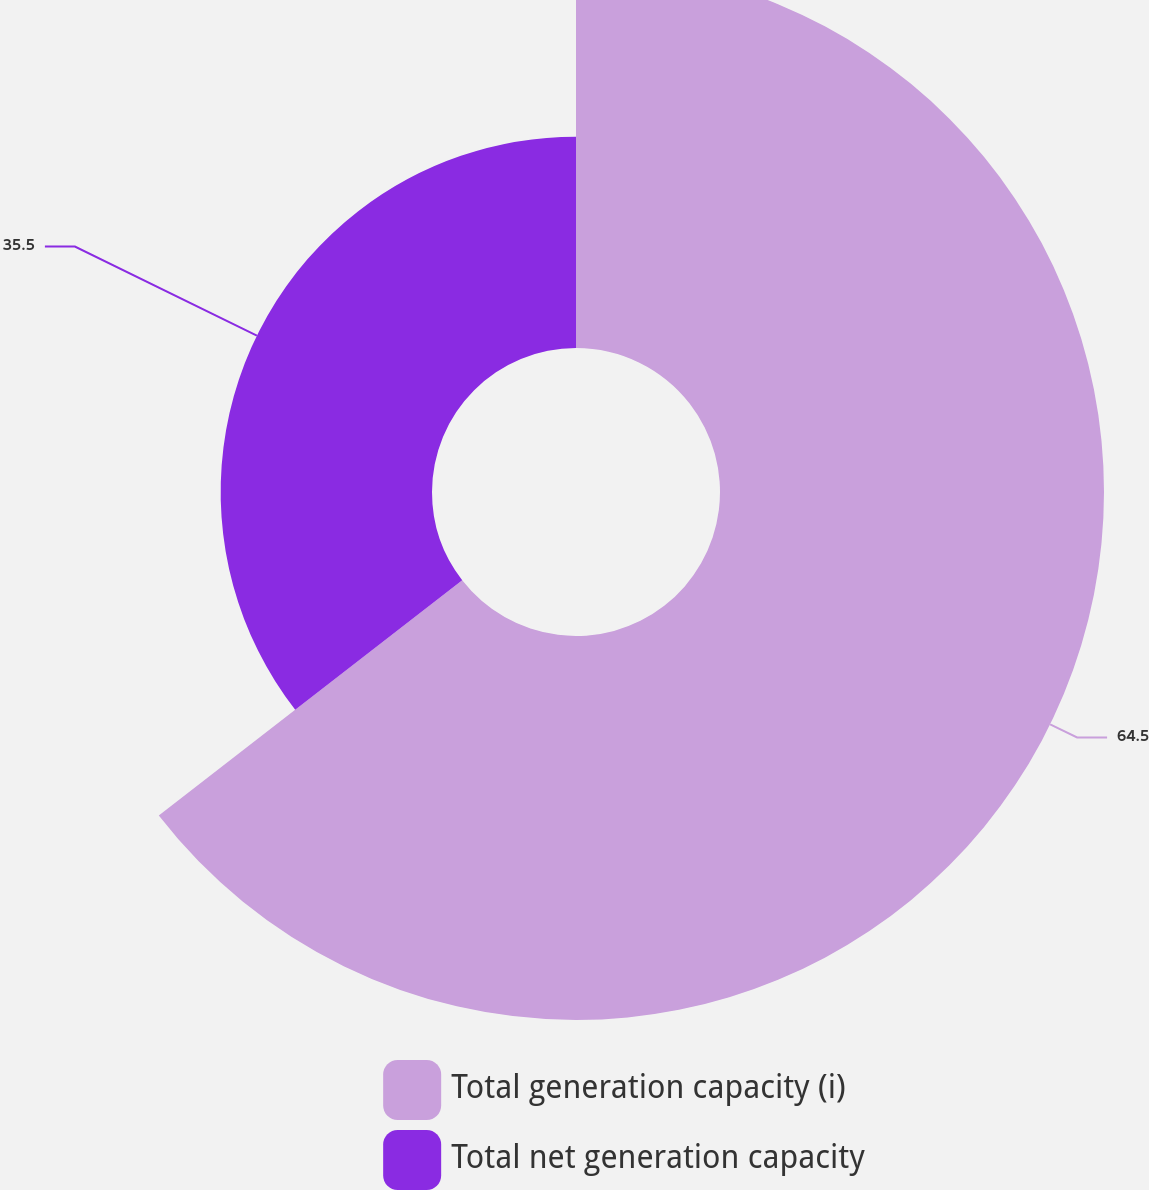<chart> <loc_0><loc_0><loc_500><loc_500><pie_chart><fcel>Total generation capacity (i)<fcel>Total net generation capacity<nl><fcel>64.5%<fcel>35.5%<nl></chart> 